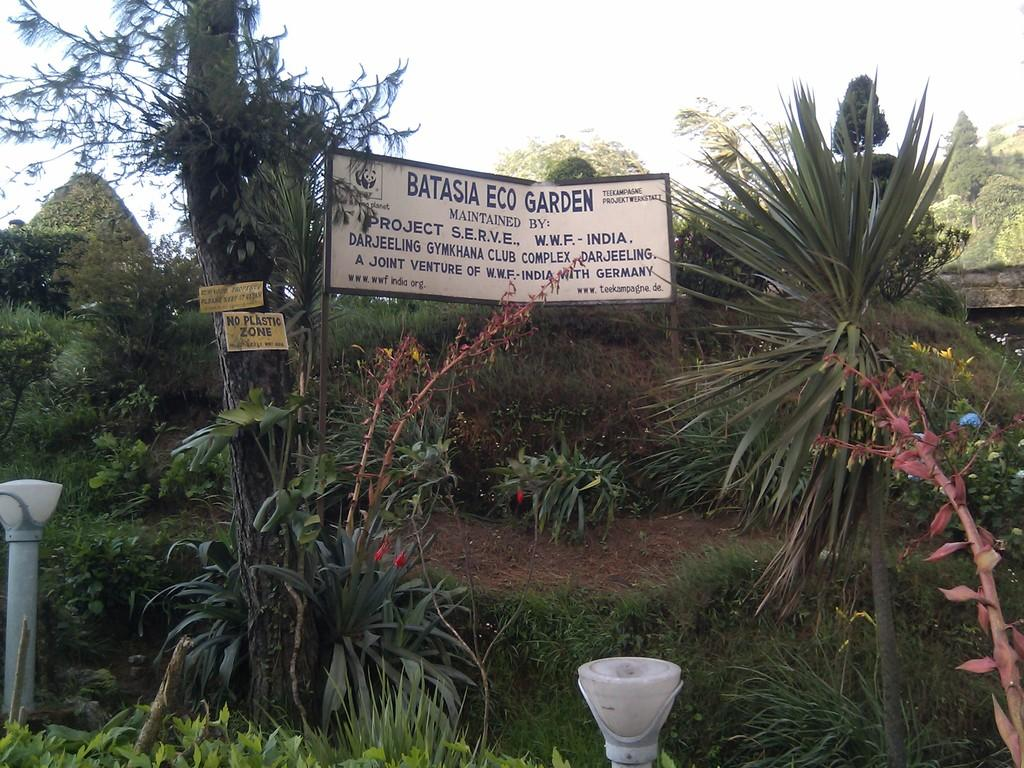What type of natural elements can be seen in the image? There are trees in the image. What man-made objects are present in the image? There are boards in the image. What color can be observed in the objects in the image? There are white color objects in the image. What is the color of the sky in the image? The sky appears to be white in color. What type of lock is used to secure the print in the image? There is no print or lock present in the image. What type of journey is depicted in the image? There is no journey depicted in the image; it features trees, boards, white objects, and a white sky. 